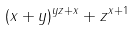Convert formula to latex. <formula><loc_0><loc_0><loc_500><loc_500>( x + y ) ^ { y z + x } + z ^ { x + 1 }</formula> 